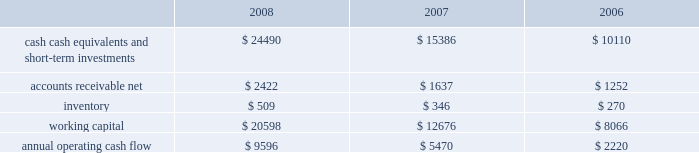Table of contents in march 2008 , the fasb issued sfas no .
161 , disclosures about derivative instruments and hedging activities 2014an amendment of fasb statement no .
133 , which requires companies to provide additional disclosures about its objectives and strategies for using derivative instruments , how the derivative instruments and related hedged items are accounted for under sfas no .
133 , accounting for derivative instruments and hedging activities , and related interpretations , and how the derivative instruments and related hedged items affect the company 2019s financial statements .
Sfas no .
161 also requires companies to disclose information about credit risk-related contingent features in their hedged positions .
Sfas no .
161 is effective for fiscal years and interim periods beginning after november 15 , 2008 and is required to be adopted by the company beginning in the second quarter of fiscal 2009 .
Although the company will continue to evaluate the application of sfas no .
161 , management does not currently believe adoption will have a material impact on the company 2019s financial condition or operating results .
Liquidity and capital resources the table presents selected financial information and statistics as of and for the three fiscal years ended september 27 , 2008 ( in millions ) : as of september 27 , 2008 , the company had $ 24.5 billion in cash , cash equivalents , and short-term investments , an increase of $ 9.1 billion from september 29 , 2007 .
The principal components of this net increase were cash generated by operating activities of $ 9.6 billion , proceeds from the issuance of common stock under stock plans of $ 483 million and excess tax benefits from stock-based compensation of $ 757 million .
These increases were partially offset by payments for acquisitions of property , plant , and equipment of $ 1.1 billion , payments made in connection with business acquisitions , net of cash acquired , of $ 220 million and payments for acquisitions of intangible assets of $ 108 million .
The company 2019s cash generated by operating activities significantly exceeded its net income due primarily to the large increase in deferred revenue , net of deferred costs , associated with subscription accounting for iphone .
The company 2019s short-term investment portfolio is invested primarily in highly rated securities with a minimum rating of single-a .
As of september 27 , 2008 and september 29 , 2007 , $ 11.3 billion and $ 6.5 billion , respectively , of the company 2019s cash , cash equivalents , and short- term investments were held by foreign subsidiaries and are generally based in u.s .
Dollar-denominated holdings .
The company had $ 117 million in net unrealized losses on its investment portfolio , primarily related to investments with stated maturities ranging from one to five years , as of september 27 , 2008 , and net unrealized losses of approximately $ 11 million on its investment portfolio , primarily related to investments with stated maturities from one to five years , as of september 29 , 2007 .
The company has the intent and ability to hold such investments for a sufficient period of time to allow for recovery of the principal amounts invested .
Accordingly , none of these declines in fair value were recognized in the company 2019s statement of operations .
The company believes its existing balances of cash , cash equivalents , and short-term investments will be sufficient to satisfy its working capital needs , capital expenditures , outstanding commitments , and other liquidity requirements associated with its existing operations over the next 12 months .
Capital assets the company 2019s cash payments for capital asset purchases were $ 1.1 billion during 2008 , consisting of $ 389 million for retail store facilities and $ 702 million for real estate acquisitions and corporate infrastructure including information systems enhancements .
The company anticipates utilizing approximately $ 1.5 billion for capital asset purchases during 2009 , including approximately $ 400 million for retail facilities and approximately $ 1.1 billion for corporate facilities and infrastructure. .

What was the increase in cash , cash equivalents , and short-term investments from 2007 to 2008 in millions? 
Computations: (24490 - 15386)
Answer: 9104.0. Table of contents in march 2008 , the fasb issued sfas no .
161 , disclosures about derivative instruments and hedging activities 2014an amendment of fasb statement no .
133 , which requires companies to provide additional disclosures about its objectives and strategies for using derivative instruments , how the derivative instruments and related hedged items are accounted for under sfas no .
133 , accounting for derivative instruments and hedging activities , and related interpretations , and how the derivative instruments and related hedged items affect the company 2019s financial statements .
Sfas no .
161 also requires companies to disclose information about credit risk-related contingent features in their hedged positions .
Sfas no .
161 is effective for fiscal years and interim periods beginning after november 15 , 2008 and is required to be adopted by the company beginning in the second quarter of fiscal 2009 .
Although the company will continue to evaluate the application of sfas no .
161 , management does not currently believe adoption will have a material impact on the company 2019s financial condition or operating results .
Liquidity and capital resources the table presents selected financial information and statistics as of and for the three fiscal years ended september 27 , 2008 ( in millions ) : as of september 27 , 2008 , the company had $ 24.5 billion in cash , cash equivalents , and short-term investments , an increase of $ 9.1 billion from september 29 , 2007 .
The principal components of this net increase were cash generated by operating activities of $ 9.6 billion , proceeds from the issuance of common stock under stock plans of $ 483 million and excess tax benefits from stock-based compensation of $ 757 million .
These increases were partially offset by payments for acquisitions of property , plant , and equipment of $ 1.1 billion , payments made in connection with business acquisitions , net of cash acquired , of $ 220 million and payments for acquisitions of intangible assets of $ 108 million .
The company 2019s cash generated by operating activities significantly exceeded its net income due primarily to the large increase in deferred revenue , net of deferred costs , associated with subscription accounting for iphone .
The company 2019s short-term investment portfolio is invested primarily in highly rated securities with a minimum rating of single-a .
As of september 27 , 2008 and september 29 , 2007 , $ 11.3 billion and $ 6.5 billion , respectively , of the company 2019s cash , cash equivalents , and short- term investments were held by foreign subsidiaries and are generally based in u.s .
Dollar-denominated holdings .
The company had $ 117 million in net unrealized losses on its investment portfolio , primarily related to investments with stated maturities ranging from one to five years , as of september 27 , 2008 , and net unrealized losses of approximately $ 11 million on its investment portfolio , primarily related to investments with stated maturities from one to five years , as of september 29 , 2007 .
The company has the intent and ability to hold such investments for a sufficient period of time to allow for recovery of the principal amounts invested .
Accordingly , none of these declines in fair value were recognized in the company 2019s statement of operations .
The company believes its existing balances of cash , cash equivalents , and short-term investments will be sufficient to satisfy its working capital needs , capital expenditures , outstanding commitments , and other liquidity requirements associated with its existing operations over the next 12 months .
Capital assets the company 2019s cash payments for capital asset purchases were $ 1.1 billion during 2008 , consisting of $ 389 million for retail store facilities and $ 702 million for real estate acquisitions and corporate infrastructure including information systems enhancements .
The company anticipates utilizing approximately $ 1.5 billion for capital asset purchases during 2009 , including approximately $ 400 million for retail facilities and approximately $ 1.1 billion for corporate facilities and infrastructure. .

Between september 27 , 2008 and september 29 , 2007 how much in billions did the company 2019s cash , cash equivalents , and short- term investments held by foreign subsidiaries increase? 
Computations: (11.3 - 6.5)
Answer: 4.8. 